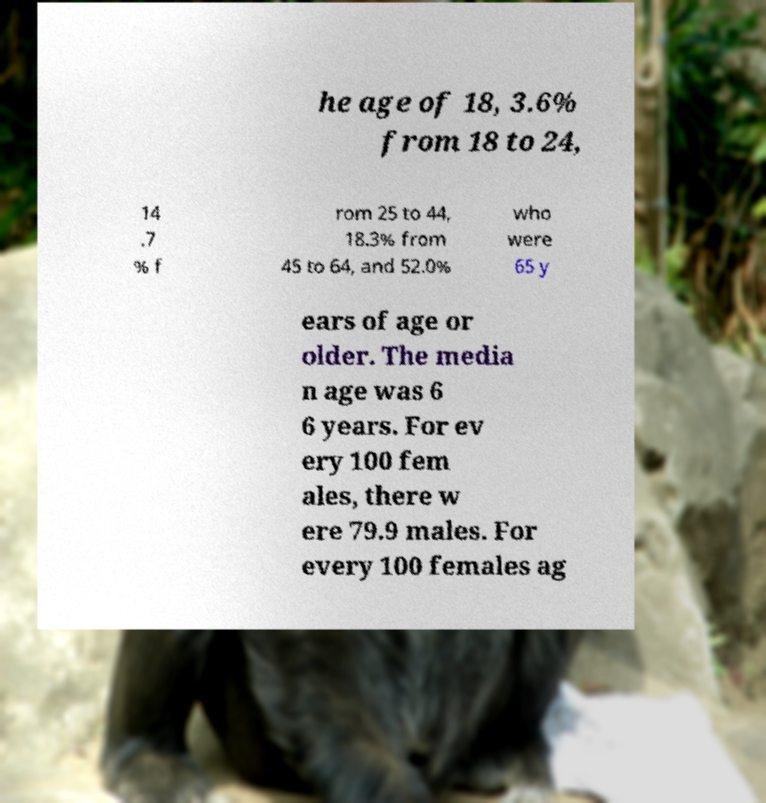For documentation purposes, I need the text within this image transcribed. Could you provide that? he age of 18, 3.6% from 18 to 24, 14 .7 % f rom 25 to 44, 18.3% from 45 to 64, and 52.0% who were 65 y ears of age or older. The media n age was 6 6 years. For ev ery 100 fem ales, there w ere 79.9 males. For every 100 females ag 